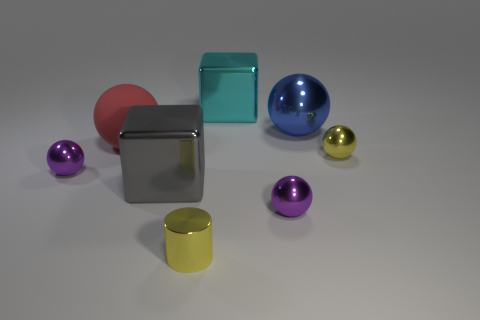Subtract all red balls. How many balls are left? 4 Subtract all cylinders. How many objects are left? 7 Add 2 large blue objects. How many large blue objects are left? 3 Add 8 large green balls. How many large green balls exist? 8 Add 1 big blue metallic cylinders. How many objects exist? 9 Subtract all gray blocks. How many blocks are left? 1 Subtract 0 green spheres. How many objects are left? 8 Subtract all yellow blocks. Subtract all purple balls. How many blocks are left? 2 Subtract all purple blocks. How many brown spheres are left? 0 Subtract all yellow objects. Subtract all tiny purple metallic objects. How many objects are left? 4 